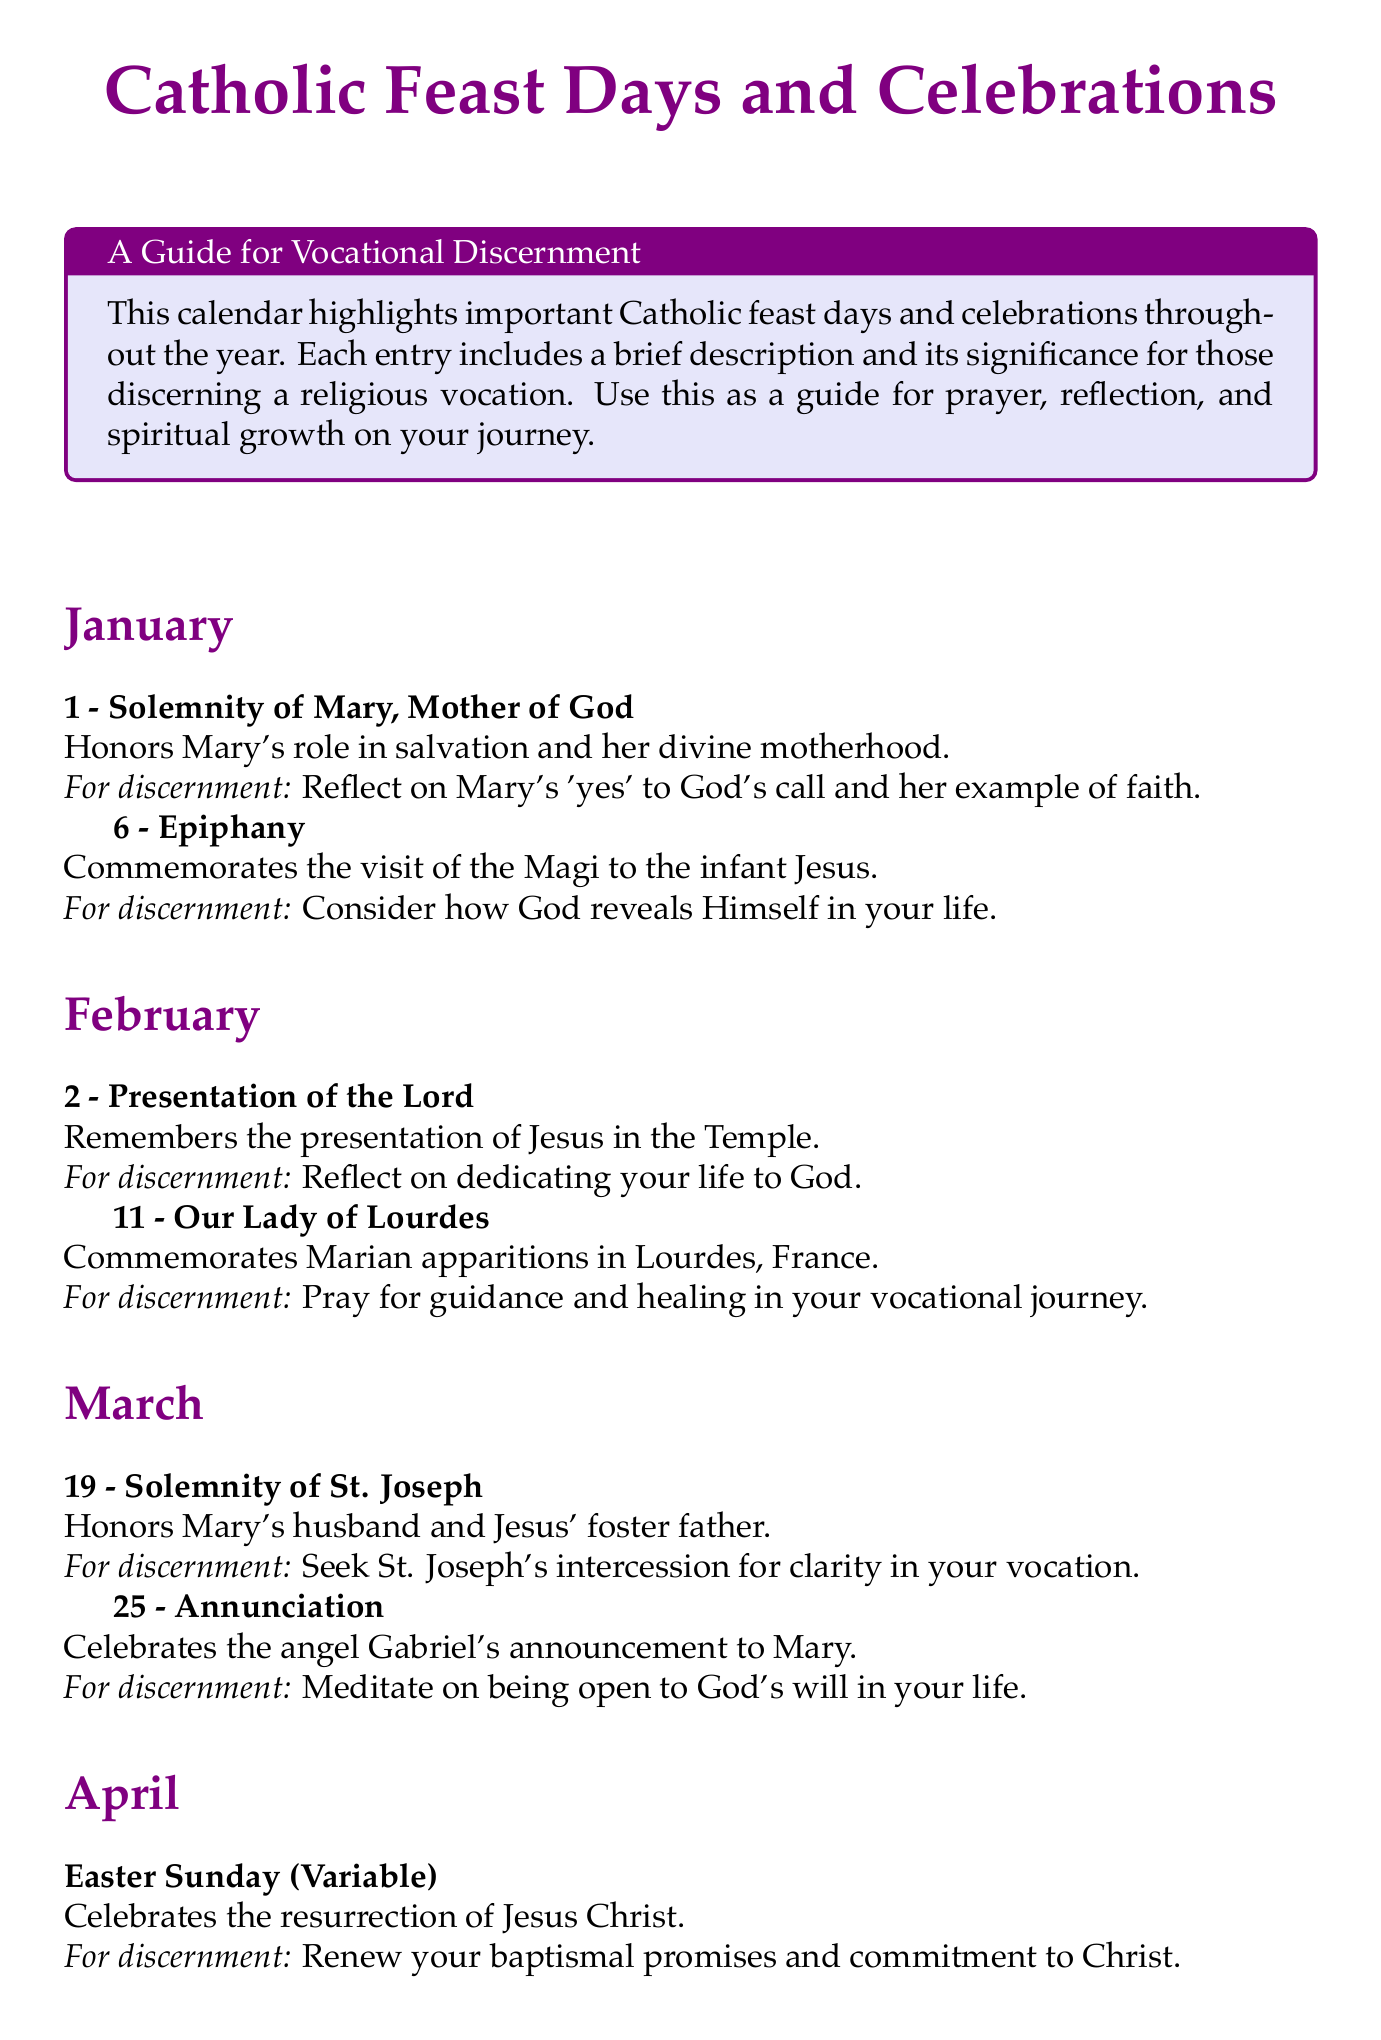what is celebrated on January 1? January 1 is the date of the Solemnity of Mary, Mother of God.
Answer: Solemnity of Mary, Mother of God what day is the Feast of St. Joseph? The Feast of St. Joseph is celebrated on March 19.
Answer: March 19 which Marian apparition is commemorated on February 11? February 11 commemorates the Marian apparitions in Lourdes, France.
Answer: Our Lady of Lourdes what is the significance of the Feast of St. Thérèse of Lisieux? The significance is to learn about her 'little way' of spiritual childhood.
Answer: Learn about her 'little way' of spiritual childhood how many celebrations are listed for the month of May? There are two celebrations listed for May in the document.
Answer: 2 what type of devotion is emphasized on Corpus Christi? Corpus Christi emphasizes devotion to the Real Presence of Christ in the Eucharist.
Answer: Real Presence of Christ in the Eucharist what does Easter Sunday celebrate? Easter Sunday celebrates the resurrection of Jesus Christ.
Answer: Resurrection of Jesus Christ what is the main theme for discernment on December 8? The main theme for discernment on December 8 is purity and holiness in religious life.
Answer: Purity and holiness in religious life 